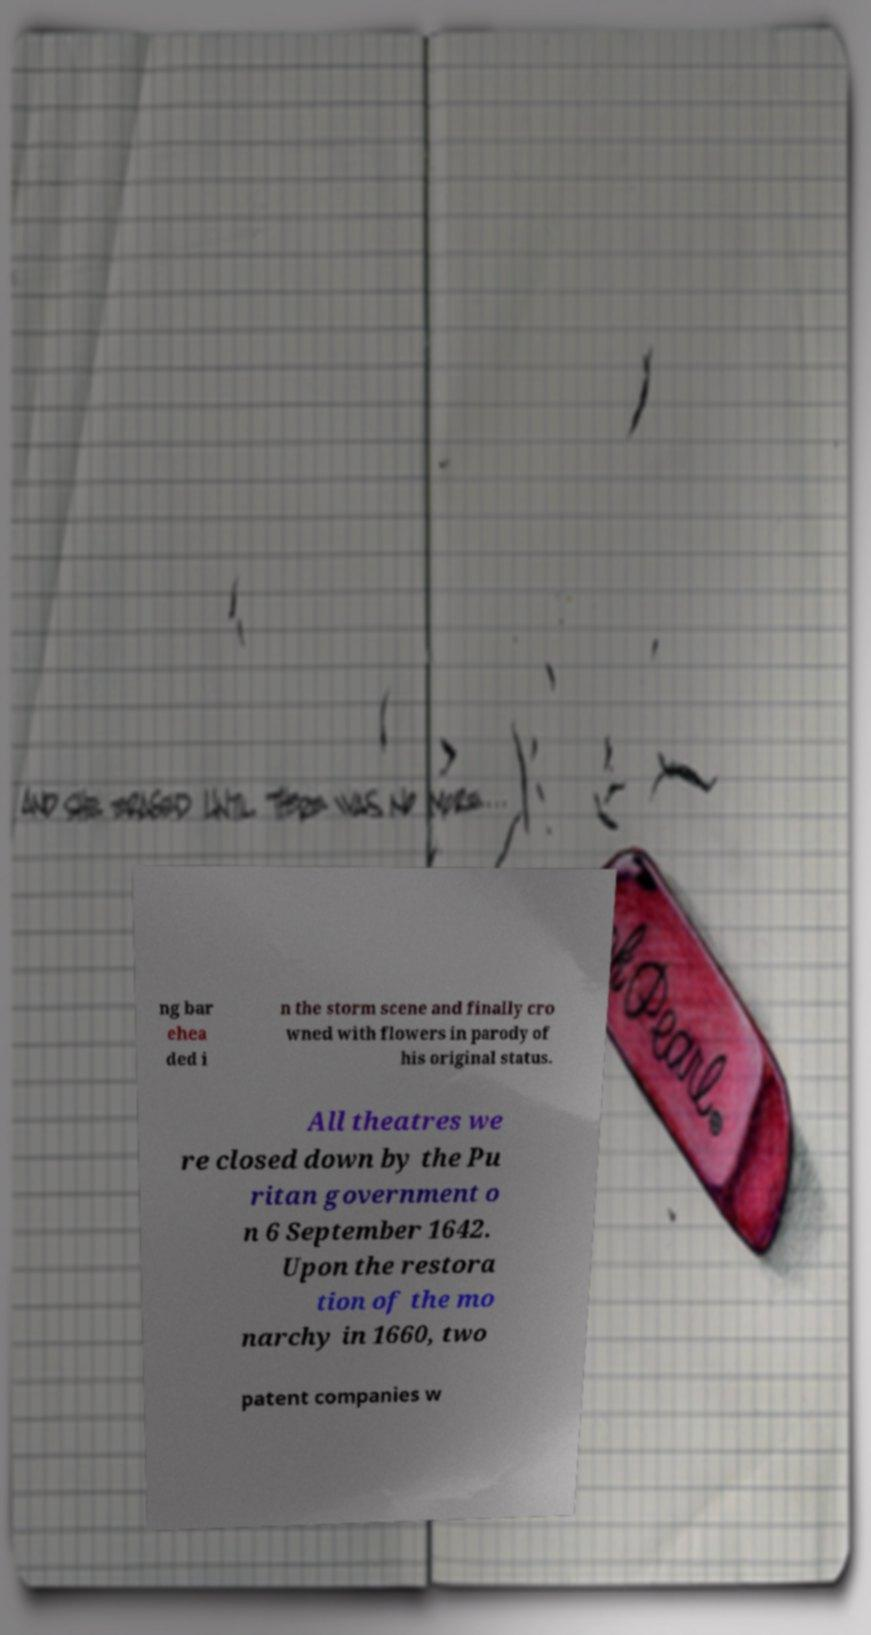Please identify and transcribe the text found in this image. ng bar ehea ded i n the storm scene and finally cro wned with flowers in parody of his original status. All theatres we re closed down by the Pu ritan government o n 6 September 1642. Upon the restora tion of the mo narchy in 1660, two patent companies w 